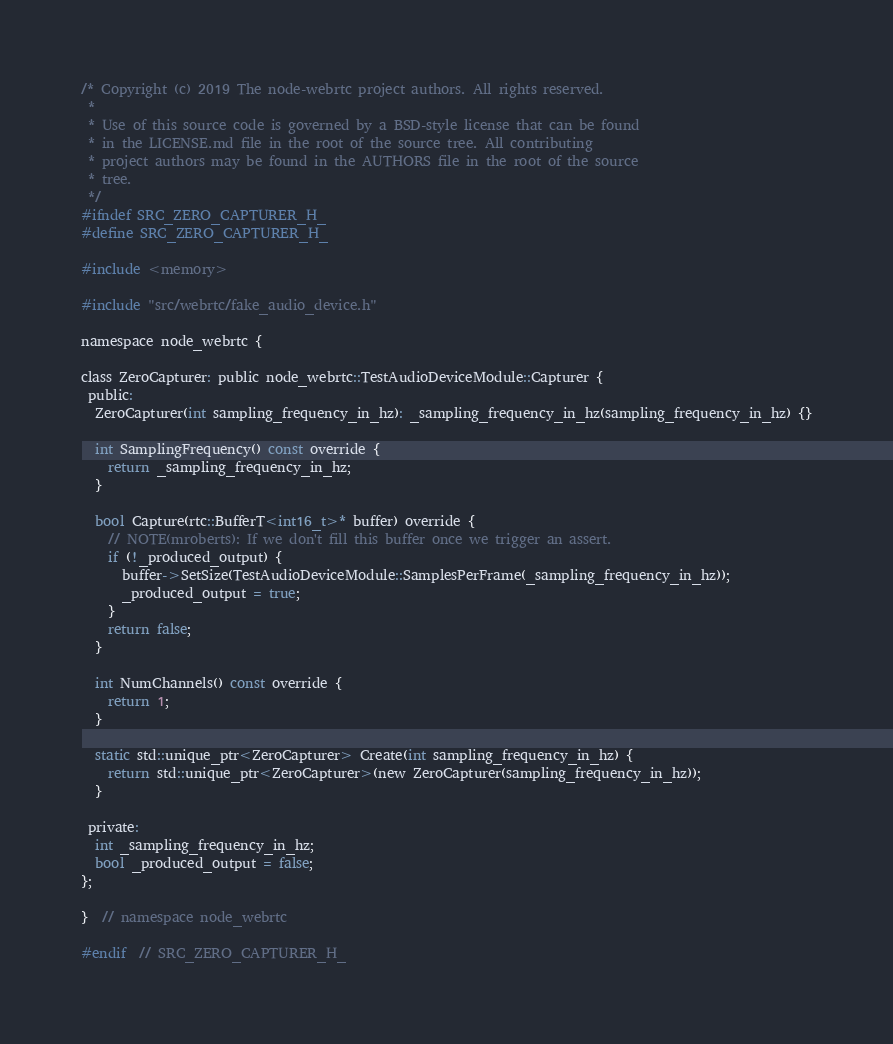Convert code to text. <code><loc_0><loc_0><loc_500><loc_500><_C_>/* Copyright (c) 2019 The node-webrtc project authors. All rights reserved.
 *
 * Use of this source code is governed by a BSD-style license that can be found
 * in the LICENSE.md file in the root of the source tree. All contributing
 * project authors may be found in the AUTHORS file in the root of the source
 * tree.
 */
#ifndef SRC_ZERO_CAPTURER_H_
#define SRC_ZERO_CAPTURER_H_

#include <memory>

#include "src/webrtc/fake_audio_device.h"

namespace node_webrtc {

class ZeroCapturer: public node_webrtc::TestAudioDeviceModule::Capturer {
 public:
  ZeroCapturer(int sampling_frequency_in_hz): _sampling_frequency_in_hz(sampling_frequency_in_hz) {}

  int SamplingFrequency() const override {
    return _sampling_frequency_in_hz;
  }

  bool Capture(rtc::BufferT<int16_t>* buffer) override {
    // NOTE(mroberts): If we don't fill this buffer once we trigger an assert.
    if (!_produced_output) {
      buffer->SetSize(TestAudioDeviceModule::SamplesPerFrame(_sampling_frequency_in_hz));
      _produced_output = true;
    }
    return false;
  }

  int NumChannels() const override {
    return 1;
  }

  static std::unique_ptr<ZeroCapturer> Create(int sampling_frequency_in_hz) {
    return std::unique_ptr<ZeroCapturer>(new ZeroCapturer(sampling_frequency_in_hz));
  }

 private:
  int _sampling_frequency_in_hz;
  bool _produced_output = false;
};

}  // namespace node_webrtc

#endif  // SRC_ZERO_CAPTURER_H_
</code> 